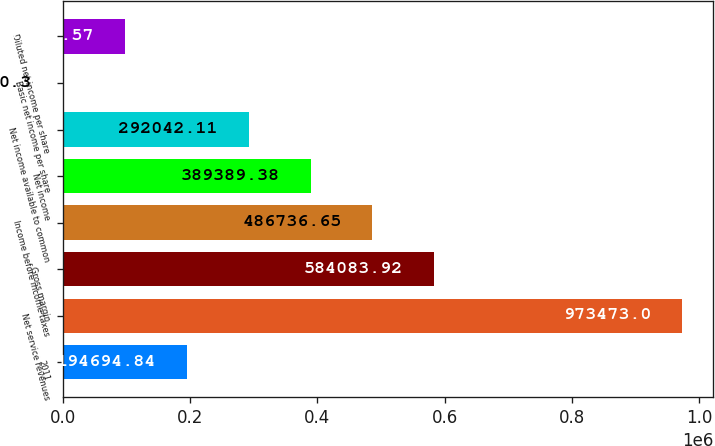<chart> <loc_0><loc_0><loc_500><loc_500><bar_chart><fcel>2011<fcel>Net service revenues<fcel>Gross margin<fcel>Income before income taxes<fcel>Net income<fcel>Net income available to common<fcel>Basic net income per share<fcel>Diluted net income per share<nl><fcel>194695<fcel>973473<fcel>584084<fcel>486737<fcel>389389<fcel>292042<fcel>0.3<fcel>97347.6<nl></chart> 